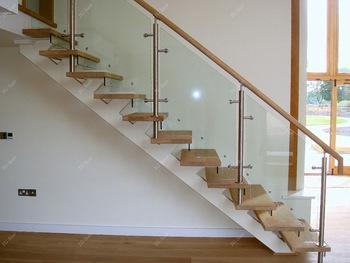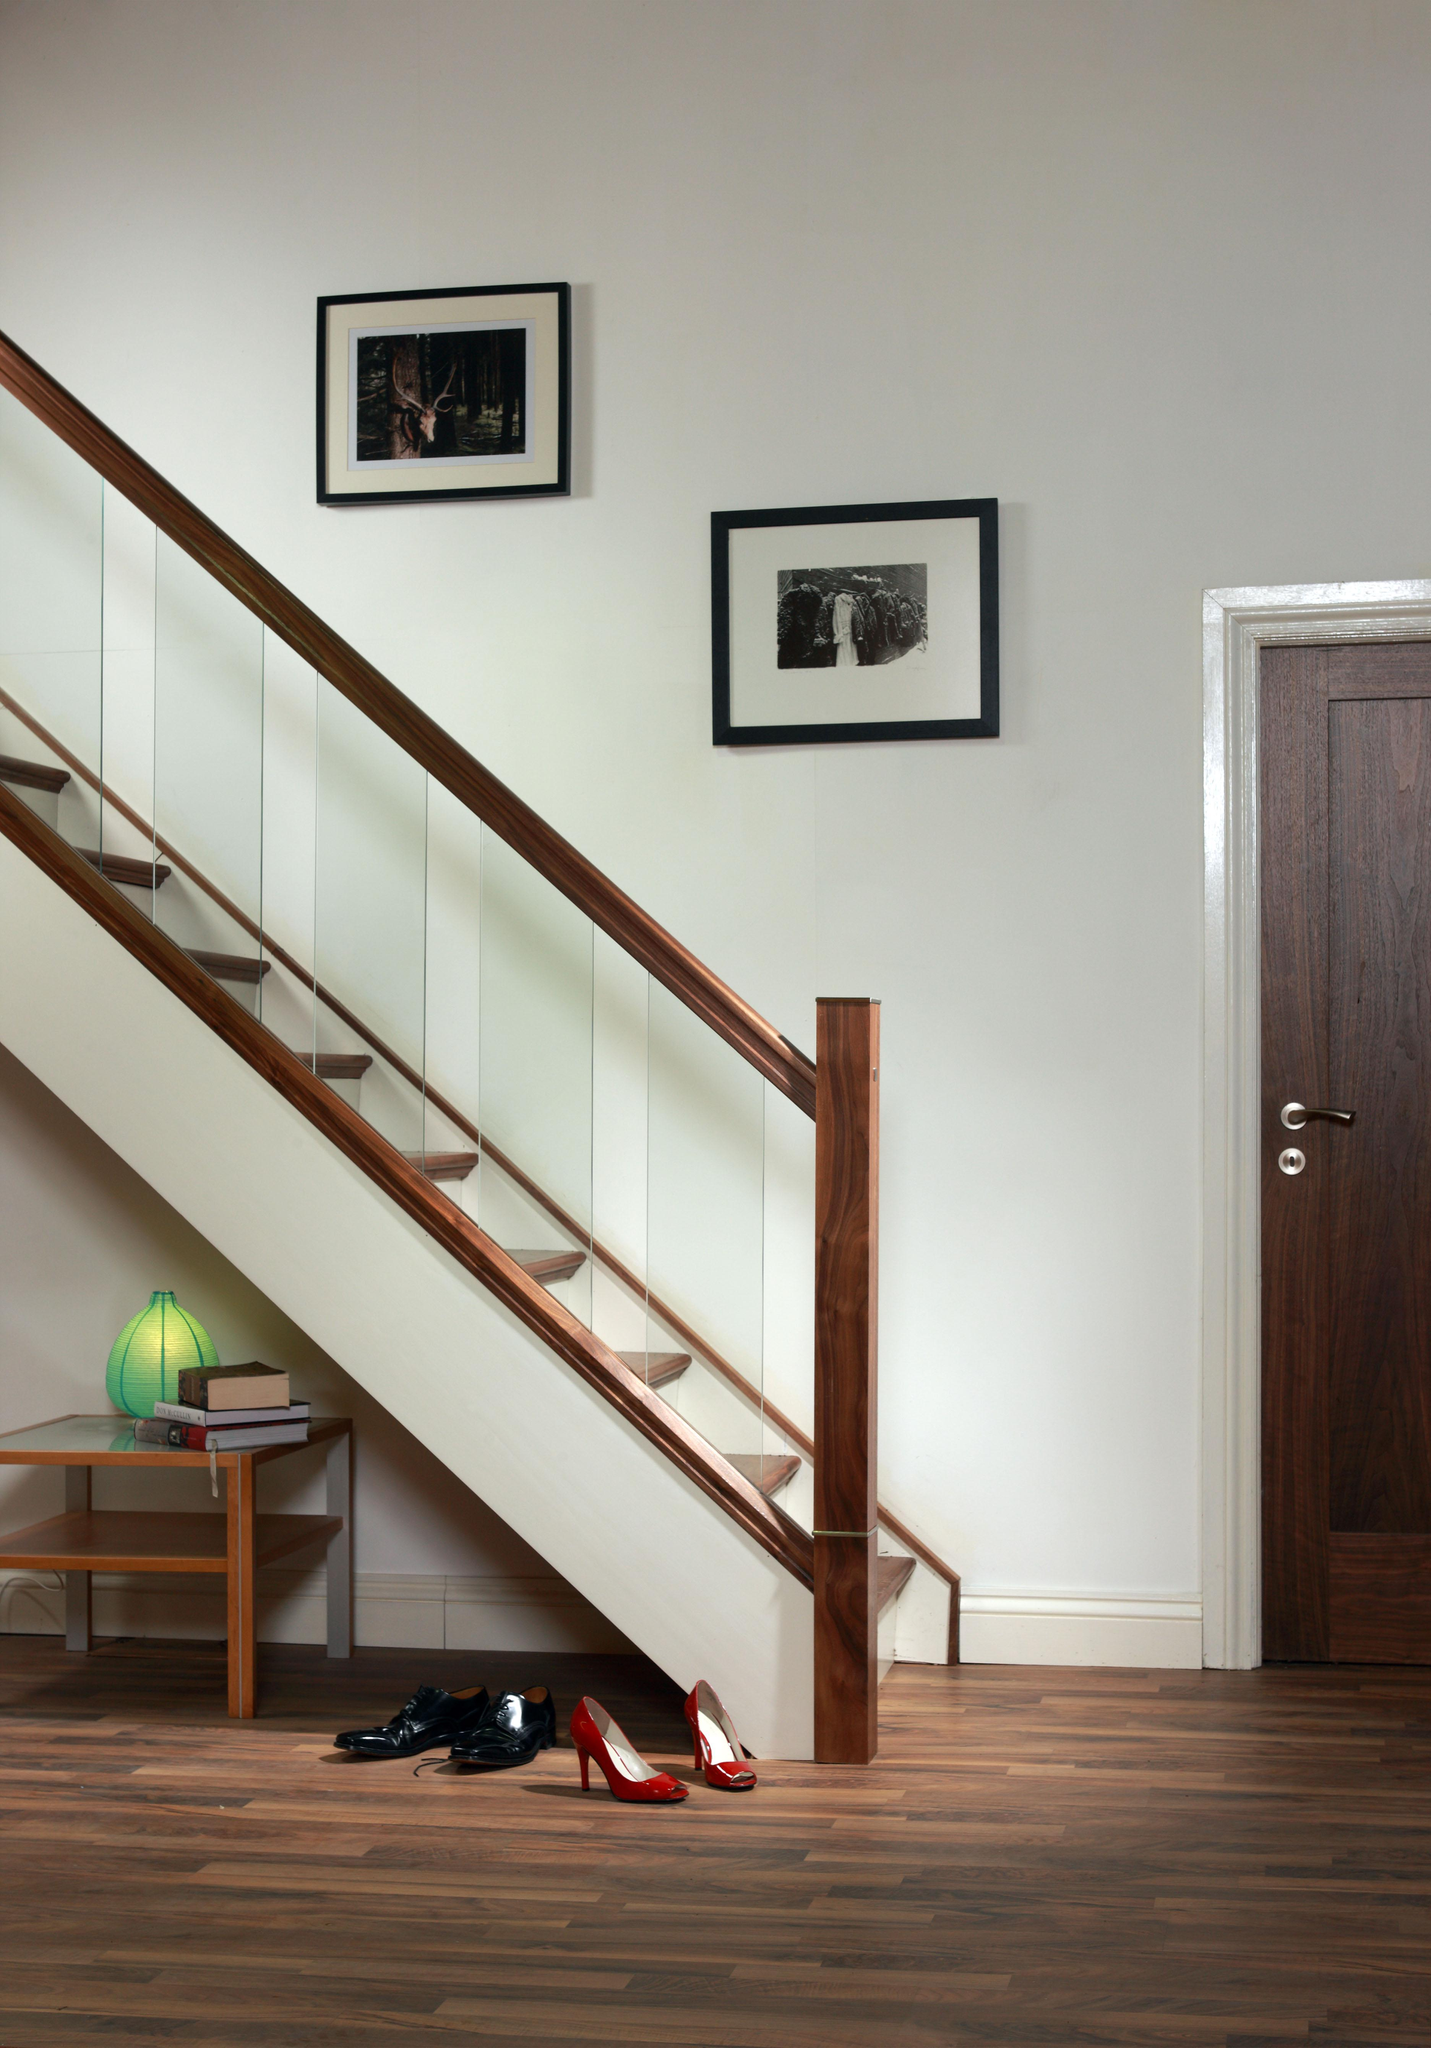The first image is the image on the left, the second image is the image on the right. Evaluate the accuracy of this statement regarding the images: "In at least one image there is a staircase facing left with three separate glass panels held up by a light brown rail.". Is it true? Answer yes or no. Yes. 